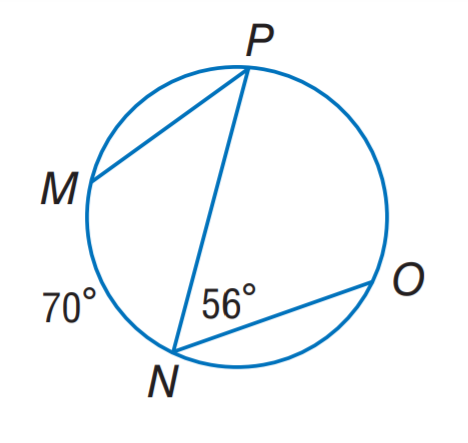Question: Find m \angle P.
Choices:
A. 28
B. 35
C. 56
D. 70
Answer with the letter. Answer: B Question: Find m \widehat P O.
Choices:
A. 56
B. 70
C. 112
D. 140
Answer with the letter. Answer: C 